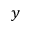<formula> <loc_0><loc_0><loc_500><loc_500>y</formula> 